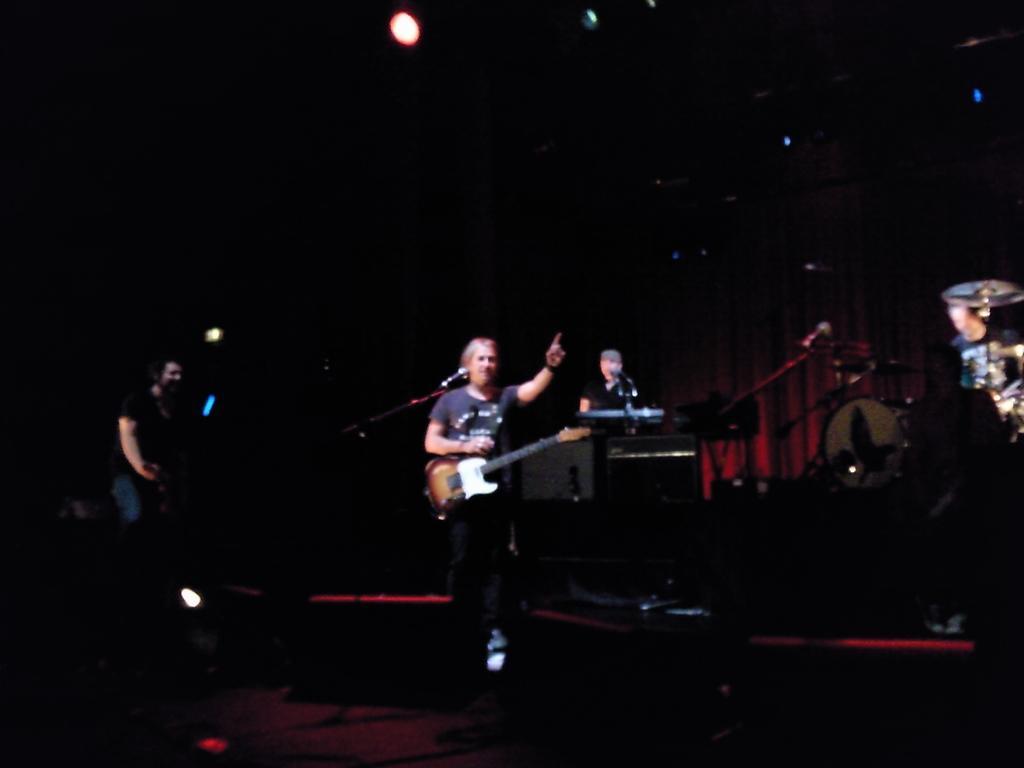Could you give a brief overview of what you see in this image? In there is a person there is man holding a guitar in the front and either sides of the image there are persons playing other musical instruments such as drums. 